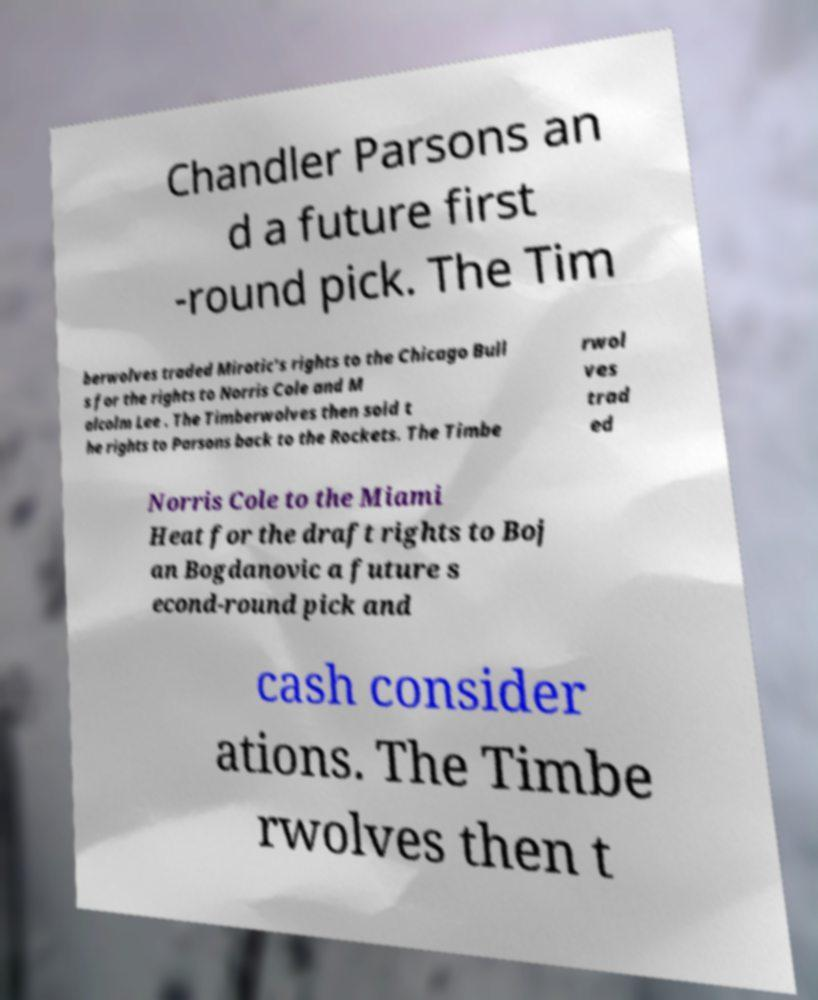Please identify and transcribe the text found in this image. Chandler Parsons an d a future first -round pick. The Tim berwolves traded Mirotic's rights to the Chicago Bull s for the rights to Norris Cole and M alcolm Lee . The Timberwolves then sold t he rights to Parsons back to the Rockets. The Timbe rwol ves trad ed Norris Cole to the Miami Heat for the draft rights to Boj an Bogdanovic a future s econd-round pick and cash consider ations. The Timbe rwolves then t 